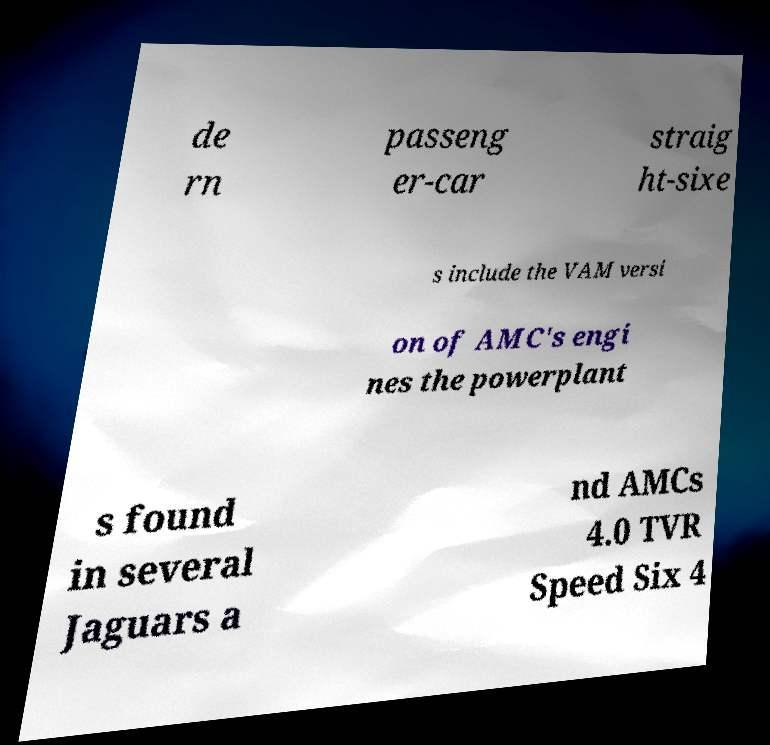I need the written content from this picture converted into text. Can you do that? de rn passeng er-car straig ht-sixe s include the VAM versi on of AMC's engi nes the powerplant s found in several Jaguars a nd AMCs 4.0 TVR Speed Six 4 